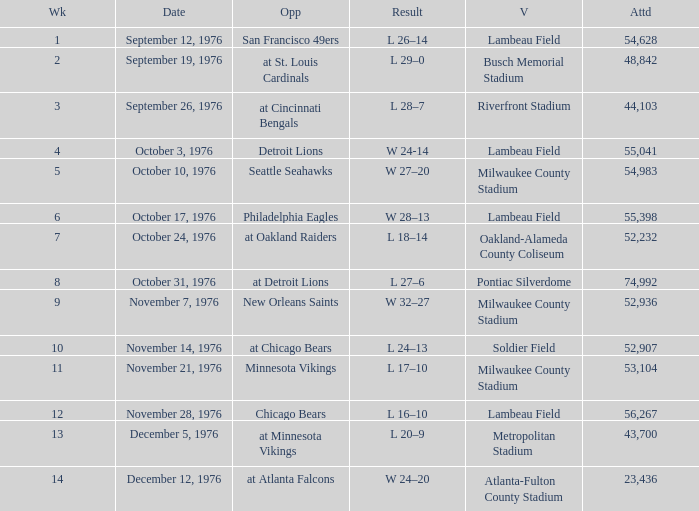How many people attended the game on September 19, 1976? 1.0. 